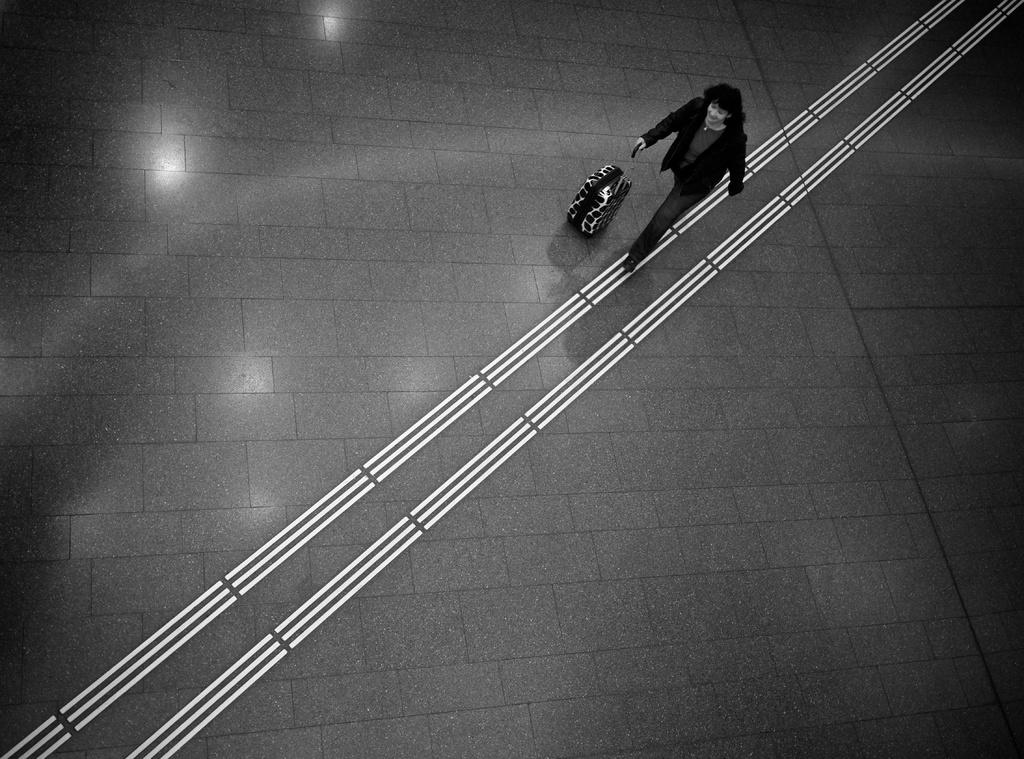What is the color scheme of the image? The image is black and white. What is the main subject of the image? There is a picture of a woman in the image. What is the woman holding in the image? The woman is holding a trolley bag. What is the woman doing in the image? The woman is walking on the floor. Reasoning: Let'ing: Let's think step by step in order to produce the conversation. We start by identifying the color scheme of the image, which is black and white. Then, we focus on the main subject, which is a picture of a woman. Next, we describe what the woman is holding, which is a trolley bag. Finally, we mention the action the woman is performing, which is walking on the floor. Each question is designed to elicit a specific detail about the image that is known from the provided facts. Absurd Question/Answer: How many stars can be seen on the woman's foot in the image? There are no stars visible on the woman's foot in the image, as it is a black and white picture and stars are not present. 